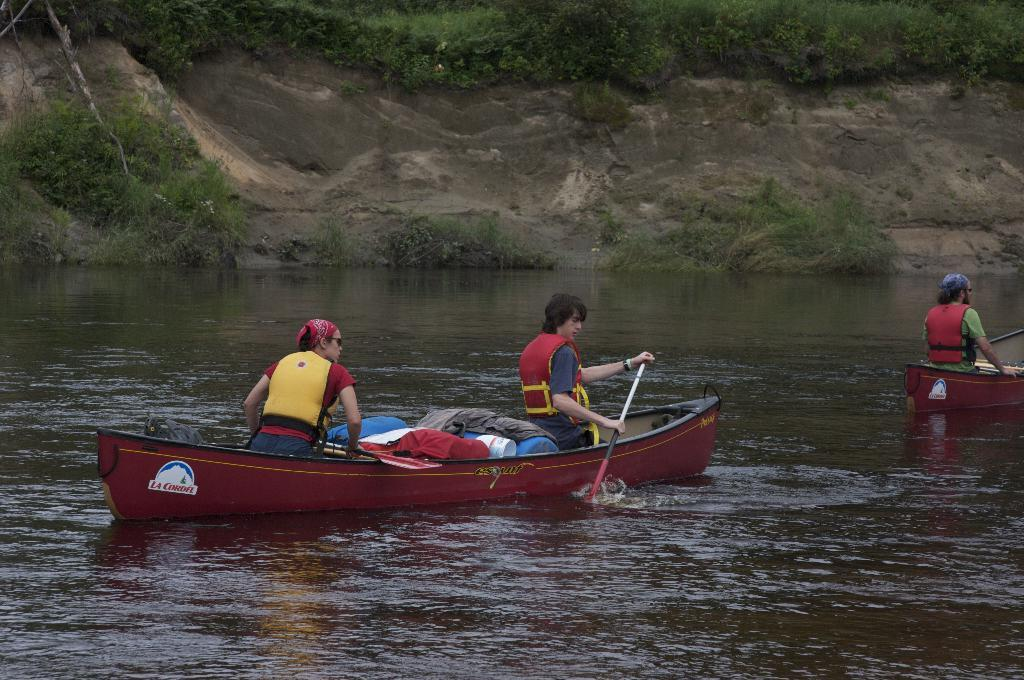What is in the water in the image? There are boats in the water. Who or what is in the boats? There are people seated in the boats. What can be seen on the hill in the image? There are plants and trees on the hill. What type of steam is coming from the dinner in the image? There is no dinner or steam present in the image. What part of the body is visible on the people in the boats? The image does not show any specific body parts of the people seated in the boats. 